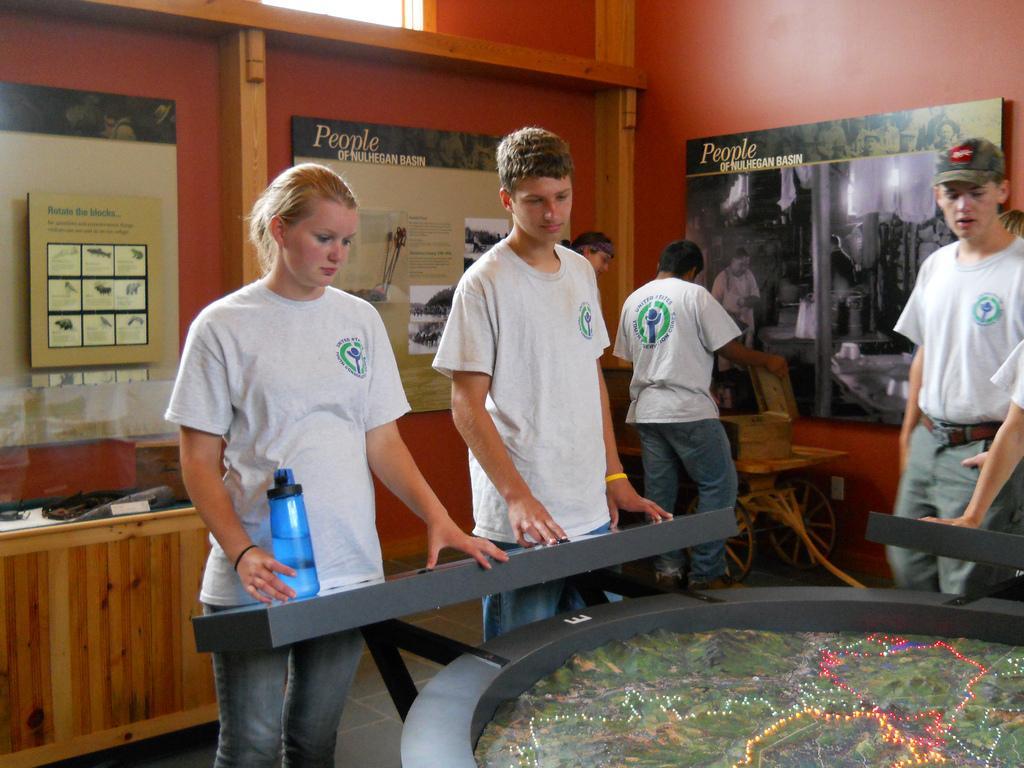Can you describe this image briefly? In this image I can see few people are standing and I can see few of them are wearing white colour t shirt. I can also see one of them is wearing a cap. Here I can see a blue colour bottle and in background I can see few boards. On these words I can see something is written. 